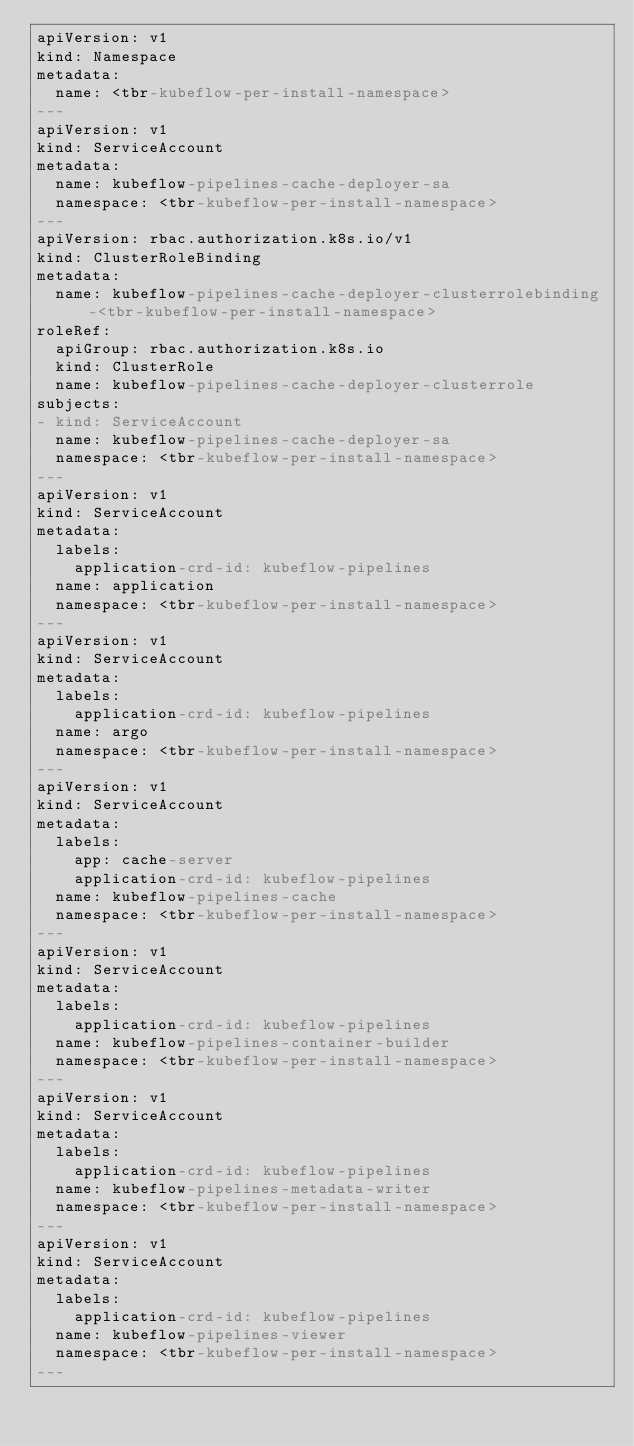<code> <loc_0><loc_0><loc_500><loc_500><_YAML_>apiVersion: v1
kind: Namespace
metadata:
  name: <tbr-kubeflow-per-install-namespace>
---
apiVersion: v1
kind: ServiceAccount
metadata:
  name: kubeflow-pipelines-cache-deployer-sa
  namespace: <tbr-kubeflow-per-install-namespace>
---
apiVersion: rbac.authorization.k8s.io/v1
kind: ClusterRoleBinding
metadata:
  name: kubeflow-pipelines-cache-deployer-clusterrolebinding-<tbr-kubeflow-per-install-namespace>
roleRef:
  apiGroup: rbac.authorization.k8s.io
  kind: ClusterRole
  name: kubeflow-pipelines-cache-deployer-clusterrole
subjects:
- kind: ServiceAccount
  name: kubeflow-pipelines-cache-deployer-sa
  namespace: <tbr-kubeflow-per-install-namespace>
---
apiVersion: v1
kind: ServiceAccount
metadata:
  labels:
    application-crd-id: kubeflow-pipelines
  name: application
  namespace: <tbr-kubeflow-per-install-namespace>
---
apiVersion: v1
kind: ServiceAccount
metadata:
  labels:
    application-crd-id: kubeflow-pipelines
  name: argo
  namespace: <tbr-kubeflow-per-install-namespace>
---
apiVersion: v1
kind: ServiceAccount
metadata:
  labels:
    app: cache-server
    application-crd-id: kubeflow-pipelines
  name: kubeflow-pipelines-cache
  namespace: <tbr-kubeflow-per-install-namespace>
---
apiVersion: v1
kind: ServiceAccount
metadata:
  labels:
    application-crd-id: kubeflow-pipelines
  name: kubeflow-pipelines-container-builder
  namespace: <tbr-kubeflow-per-install-namespace>
---
apiVersion: v1
kind: ServiceAccount
metadata:
  labels:
    application-crd-id: kubeflow-pipelines
  name: kubeflow-pipelines-metadata-writer
  namespace: <tbr-kubeflow-per-install-namespace>
---
apiVersion: v1
kind: ServiceAccount
metadata:
  labels:
    application-crd-id: kubeflow-pipelines
  name: kubeflow-pipelines-viewer
  namespace: <tbr-kubeflow-per-install-namespace>
---</code> 